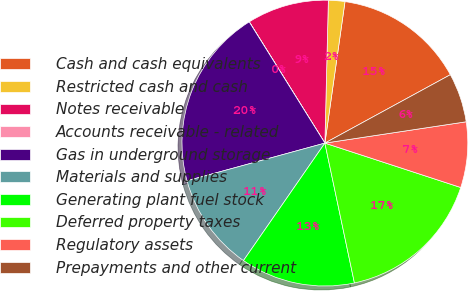Convert chart to OTSL. <chart><loc_0><loc_0><loc_500><loc_500><pie_chart><fcel>Cash and cash equivalents<fcel>Restricted cash and cash<fcel>Notes receivable<fcel>Accounts receivable - related<fcel>Gas in underground storage<fcel>Materials and supplies<fcel>Generating plant fuel stock<fcel>Deferred property taxes<fcel>Regulatory assets<fcel>Prepayments and other current<nl><fcel>14.81%<fcel>1.86%<fcel>9.26%<fcel>0.01%<fcel>20.36%<fcel>11.11%<fcel>12.96%<fcel>16.66%<fcel>7.41%<fcel>5.56%<nl></chart> 